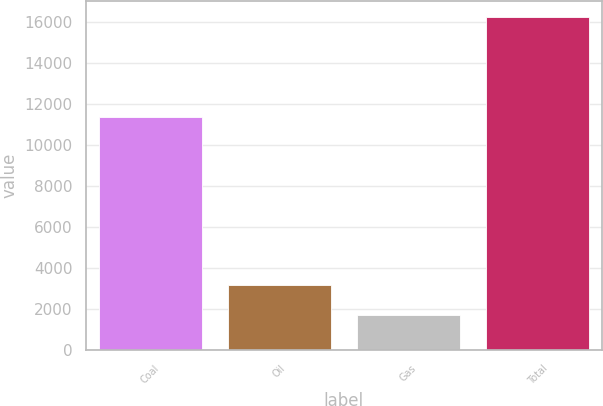<chart> <loc_0><loc_0><loc_500><loc_500><bar_chart><fcel>Coal<fcel>Oil<fcel>Gas<fcel>Total<nl><fcel>11363<fcel>3186.1<fcel>1735<fcel>16246<nl></chart> 